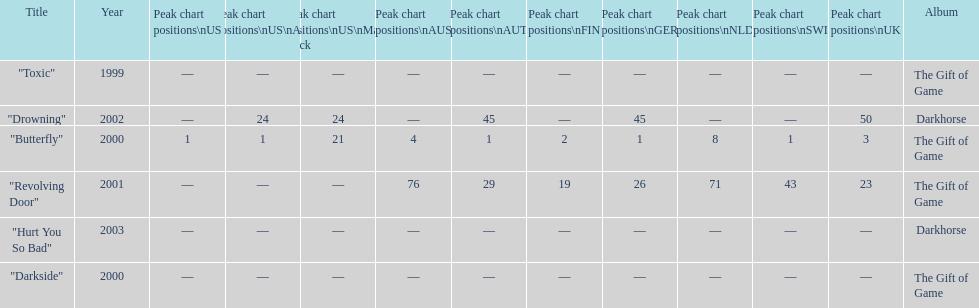Which single ranks 1 in us and 1 in us alt? "Butterfly". 